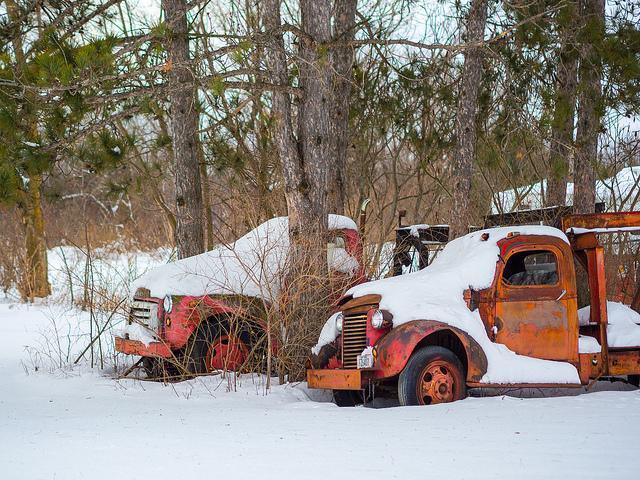How many trucks are visible?
Give a very brief answer. 2. How many laptops are visible?
Give a very brief answer. 0. 